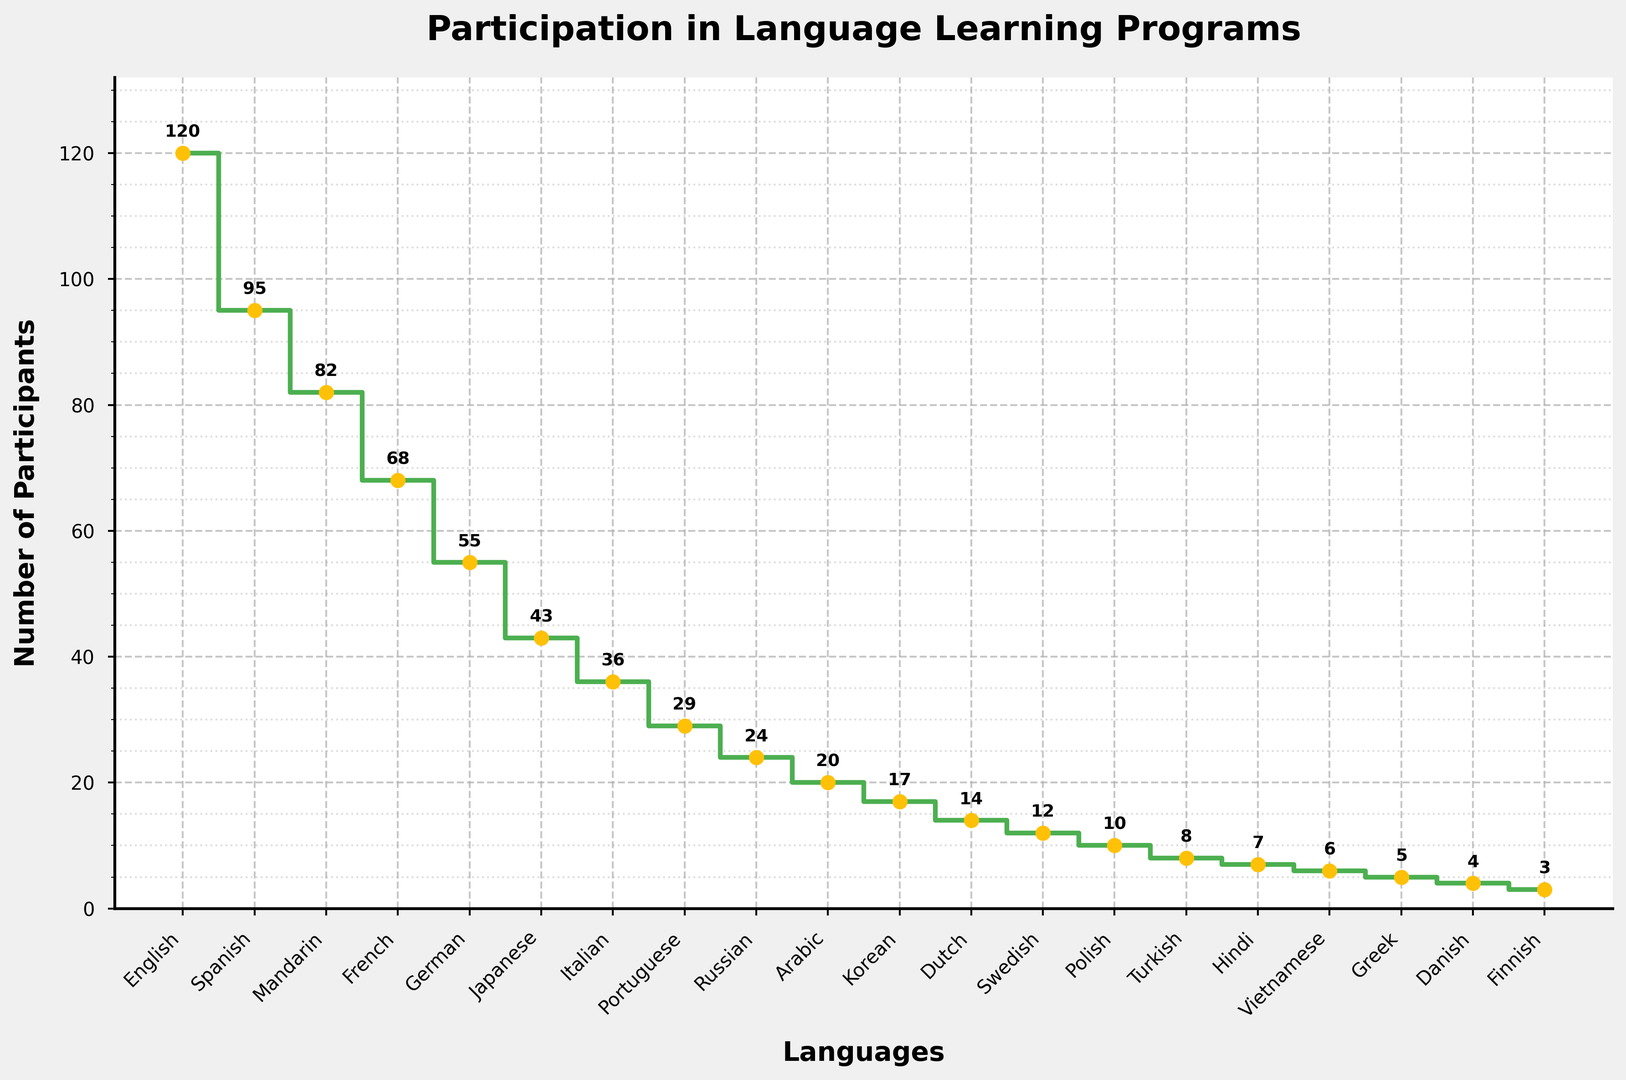Which language learning program has the highest number of participants? The highest point on the stairs plot corresponds to the language on the x-axis. The highest number of participants is 120, which corresponds to the English program.
Answer: English How many more participants are there in the Spanish program compared to the Japanese program? To find the difference in participants, subtract the number of Japanese program participants (43) from the number of Spanish program participants (95). 95 - 43 = 52
Answer: 52 What is the total number of participants in the top three language programs? Sum the number of participants in the top three programs: English (120), Spanish (95), and Mandarin (82). 120 + 95 + 82 = 297
Answer: 297 Which programs have fewer than 10 participants? Look at the participant values and identify those below 10, which are Hindi (7), Vietnamese (6), Greek (5), Danish (4), and Finnish (3).
Answer: Hindi, Vietnamese, Greek, Danish, Finnish How many participants does the French program have compared to the German program? Comparing the two, French has 68 participants and German has 55. To find the difference, 68 - 55 = 13
Answer: 13 Which language program has a lower number of participants than the Portuguese program but higher than the Russian program? The Portuguese program has 29 participants and the Russian program has 24 participants. The language that fits is Italian with 36 participants.
Answer: Italian What is the average number of participants in the German, Japanese, and Italian programs? Sum the participants of the German, Japanese, and Italian programs (55 + 43 + 36) and divide by the number of programs. (55 + 43 + 36) / 3 = 44.67
Answer: 44.67 Between the Arabic and Korean programs, which has more participants, and by how many? Arabic has 20 participants, and Korean has 17. The difference is 20 - 17 = 3
Answer: Arabic, 3 How many participants are there in language programs Hindi and Greek combined? Sum participants of Hindi (7) and Greek (5). 7 + 5 = 12
Answer: 12 Which color represents the markers used in the plot? The visual attribute of the markers is described as having a yellow face color.
Answer: Yellow 